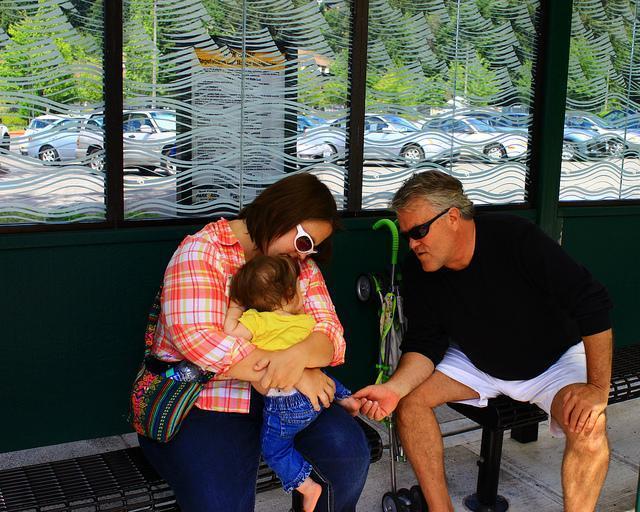How many people can you see?
Give a very brief answer. 3. How many benches are there?
Give a very brief answer. 2. How many cars are in the picture?
Give a very brief answer. 6. 